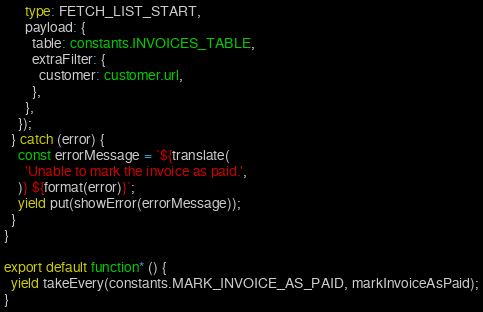<code> <loc_0><loc_0><loc_500><loc_500><_TypeScript_>      type: FETCH_LIST_START,
      payload: {
        table: constants.INVOICES_TABLE,
        extraFilter: {
          customer: customer.url,
        },
      },
    });
  } catch (error) {
    const errorMessage = `${translate(
      'Unable to mark the invoice as paid.',
    )} ${format(error)}`;
    yield put(showError(errorMessage));
  }
}

export default function* () {
  yield takeEvery(constants.MARK_INVOICE_AS_PAID, markInvoiceAsPaid);
}
</code> 